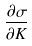Convert formula to latex. <formula><loc_0><loc_0><loc_500><loc_500>\frac { \partial \sigma } { \partial K }</formula> 